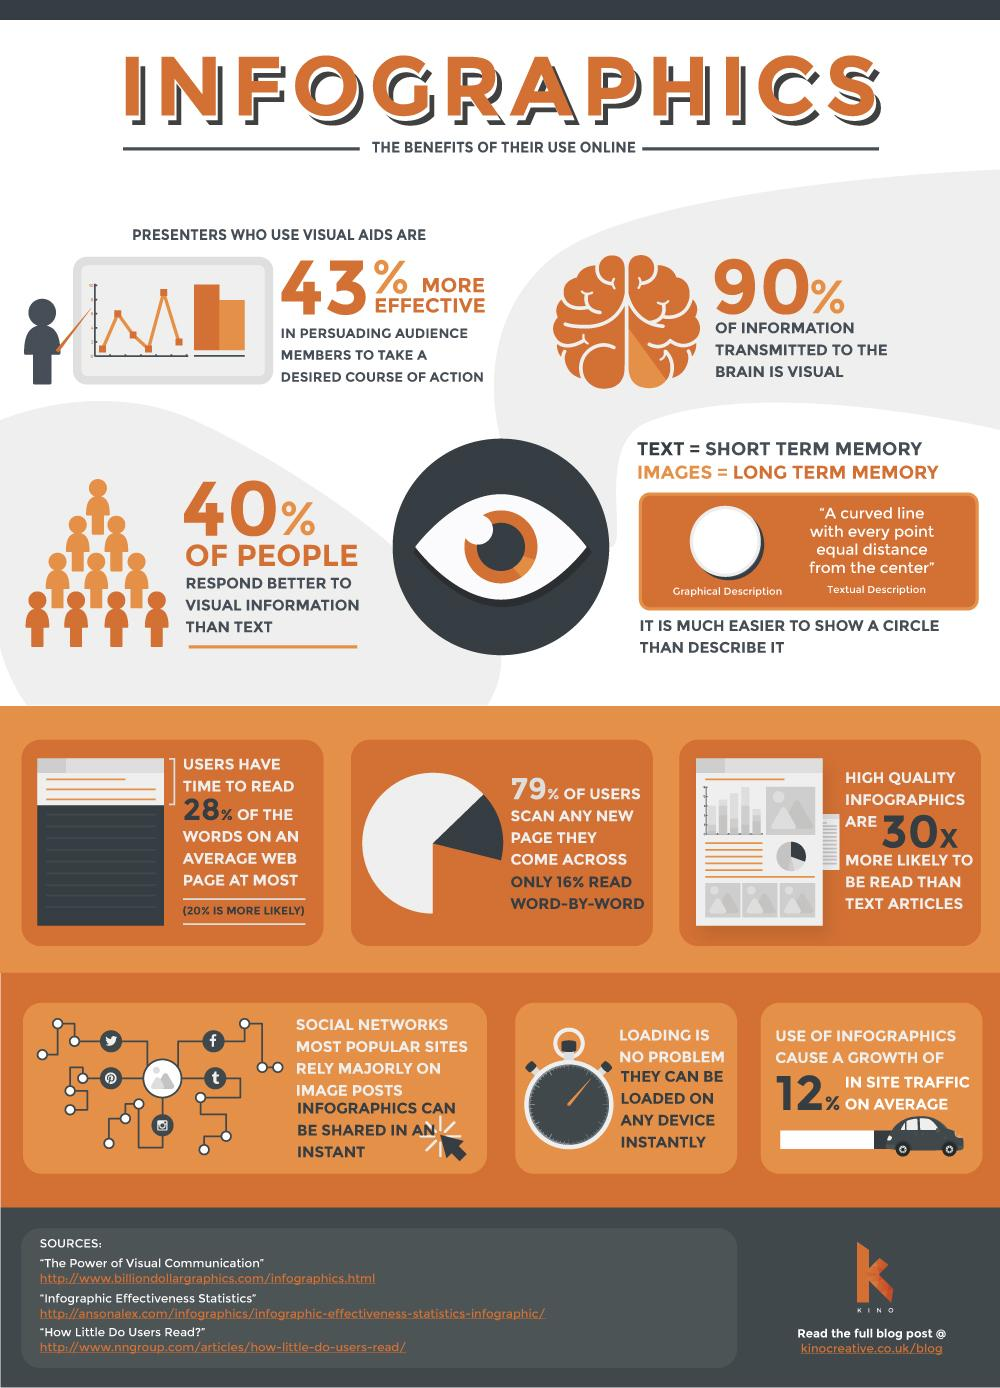Give some essential details in this illustration. High quality infographics are preferred over text articles. There are a total of 3 sources listed. 